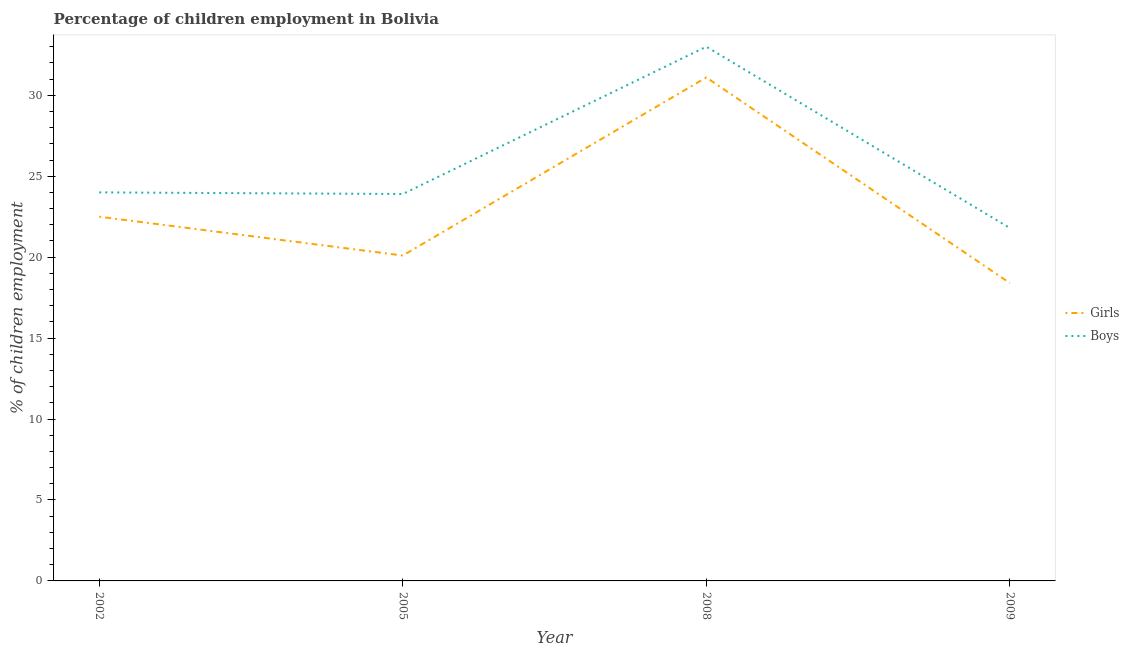What is the percentage of employed girls in 2002?
Offer a terse response. 22.5. In which year was the percentage of employed boys maximum?
Offer a very short reply. 2008. In which year was the percentage of employed girls minimum?
Your response must be concise. 2009. What is the total percentage of employed boys in the graph?
Provide a succinct answer. 102.7. What is the difference between the percentage of employed boys in 2005 and that in 2009?
Provide a succinct answer. 2.1. What is the difference between the percentage of employed boys in 2005 and the percentage of employed girls in 2008?
Make the answer very short. -7.2. What is the average percentage of employed boys per year?
Offer a very short reply. 25.68. In the year 2009, what is the difference between the percentage of employed boys and percentage of employed girls?
Your answer should be very brief. 3.4. What is the ratio of the percentage of employed boys in 2002 to that in 2008?
Offer a very short reply. 0.73. What is the difference between the highest and the second highest percentage of employed boys?
Give a very brief answer. 9. What is the difference between the highest and the lowest percentage of employed girls?
Provide a short and direct response. 12.7. In how many years, is the percentage of employed boys greater than the average percentage of employed boys taken over all years?
Keep it short and to the point. 1. Is the sum of the percentage of employed boys in 2002 and 2008 greater than the maximum percentage of employed girls across all years?
Give a very brief answer. Yes. Is the percentage of employed boys strictly greater than the percentage of employed girls over the years?
Ensure brevity in your answer.  Yes. Is the percentage of employed boys strictly less than the percentage of employed girls over the years?
Your answer should be very brief. No. How many lines are there?
Provide a succinct answer. 2. What is the difference between two consecutive major ticks on the Y-axis?
Your response must be concise. 5. Does the graph contain grids?
Offer a very short reply. No. Where does the legend appear in the graph?
Ensure brevity in your answer.  Center right. What is the title of the graph?
Provide a short and direct response. Percentage of children employment in Bolivia. What is the label or title of the X-axis?
Ensure brevity in your answer.  Year. What is the label or title of the Y-axis?
Keep it short and to the point. % of children employment. What is the % of children employment in Girls in 2002?
Provide a succinct answer. 22.5. What is the % of children employment of Girls in 2005?
Make the answer very short. 20.1. What is the % of children employment in Boys in 2005?
Keep it short and to the point. 23.9. What is the % of children employment in Girls in 2008?
Your answer should be very brief. 31.1. What is the % of children employment of Boys in 2008?
Offer a very short reply. 33. What is the % of children employment in Girls in 2009?
Provide a short and direct response. 18.4. What is the % of children employment of Boys in 2009?
Ensure brevity in your answer.  21.8. Across all years, what is the maximum % of children employment in Girls?
Give a very brief answer. 31.1. Across all years, what is the maximum % of children employment of Boys?
Offer a terse response. 33. Across all years, what is the minimum % of children employment of Girls?
Your answer should be compact. 18.4. Across all years, what is the minimum % of children employment in Boys?
Keep it short and to the point. 21.8. What is the total % of children employment in Girls in the graph?
Your answer should be very brief. 92.1. What is the total % of children employment in Boys in the graph?
Your answer should be very brief. 102.7. What is the difference between the % of children employment in Girls in 2002 and that in 2008?
Your answer should be very brief. -8.6. What is the difference between the % of children employment of Girls in 2002 and that in 2009?
Provide a short and direct response. 4.1. What is the difference between the % of children employment in Girls in 2005 and that in 2009?
Provide a succinct answer. 1.7. What is the difference between the % of children employment in Boys in 2005 and that in 2009?
Offer a very short reply. 2.1. What is the difference between the % of children employment in Boys in 2008 and that in 2009?
Make the answer very short. 11.2. What is the difference between the % of children employment of Girls in 2002 and the % of children employment of Boys in 2005?
Offer a terse response. -1.4. What is the difference between the % of children employment in Girls in 2002 and the % of children employment in Boys in 2008?
Offer a terse response. -10.5. What is the difference between the % of children employment of Girls in 2005 and the % of children employment of Boys in 2008?
Make the answer very short. -12.9. What is the average % of children employment of Girls per year?
Ensure brevity in your answer.  23.02. What is the average % of children employment of Boys per year?
Offer a very short reply. 25.68. In the year 2002, what is the difference between the % of children employment of Girls and % of children employment of Boys?
Your answer should be very brief. -1.5. In the year 2005, what is the difference between the % of children employment of Girls and % of children employment of Boys?
Keep it short and to the point. -3.8. In the year 2009, what is the difference between the % of children employment in Girls and % of children employment in Boys?
Provide a short and direct response. -3.4. What is the ratio of the % of children employment of Girls in 2002 to that in 2005?
Provide a short and direct response. 1.12. What is the ratio of the % of children employment in Girls in 2002 to that in 2008?
Your answer should be compact. 0.72. What is the ratio of the % of children employment in Boys in 2002 to that in 2008?
Offer a terse response. 0.73. What is the ratio of the % of children employment of Girls in 2002 to that in 2009?
Your response must be concise. 1.22. What is the ratio of the % of children employment in Boys in 2002 to that in 2009?
Offer a terse response. 1.1. What is the ratio of the % of children employment of Girls in 2005 to that in 2008?
Ensure brevity in your answer.  0.65. What is the ratio of the % of children employment of Boys in 2005 to that in 2008?
Offer a very short reply. 0.72. What is the ratio of the % of children employment in Girls in 2005 to that in 2009?
Provide a short and direct response. 1.09. What is the ratio of the % of children employment in Boys in 2005 to that in 2009?
Your answer should be compact. 1.1. What is the ratio of the % of children employment of Girls in 2008 to that in 2009?
Provide a short and direct response. 1.69. What is the ratio of the % of children employment of Boys in 2008 to that in 2009?
Your answer should be very brief. 1.51. What is the difference between the highest and the second highest % of children employment in Girls?
Offer a very short reply. 8.6. What is the difference between the highest and the second highest % of children employment in Boys?
Keep it short and to the point. 9. What is the difference between the highest and the lowest % of children employment of Boys?
Make the answer very short. 11.2. 